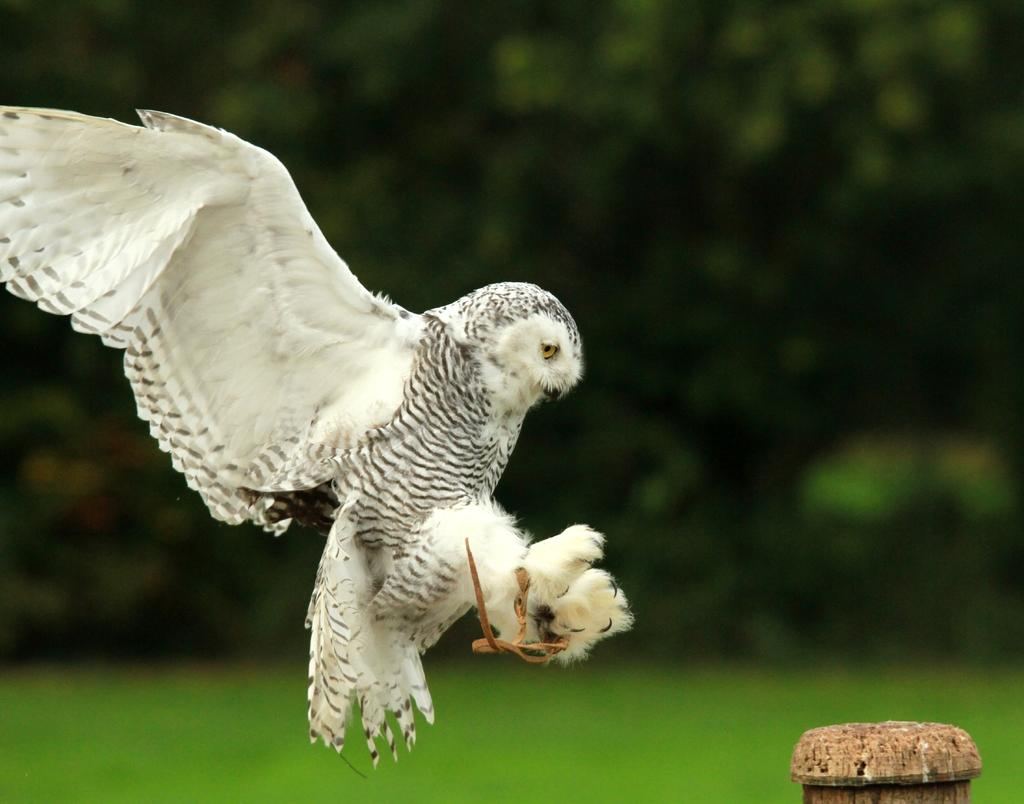What is the main subject of the image? There is a bird flying in the image. What can be seen in the background of the image? There are trees in the background of the image. What type of surface is visible in the image? There is ground visible in the image. What type of boot is the bird wearing in the image? There is no boot present in the image, as birds do not wear boots. 